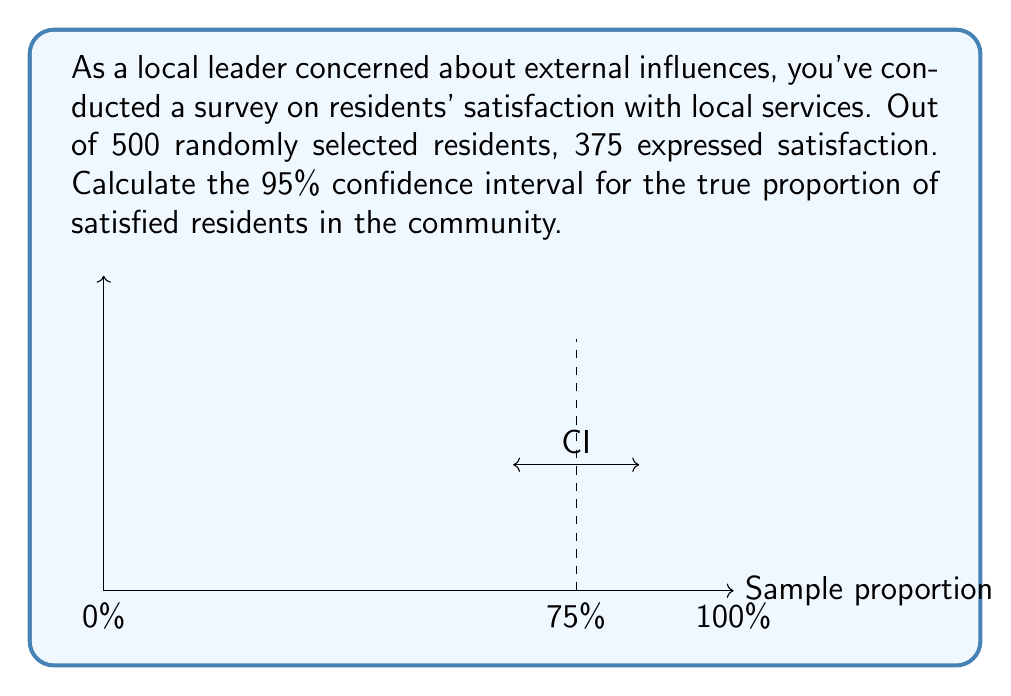Could you help me with this problem? Let's approach this step-by-step:

1) First, we need to calculate the sample proportion:
   $\hat{p} = \frac{375}{500} = 0.75$ or 75%

2) The formula for the confidence interval is:
   $$\hat{p} \pm z_{\alpha/2} \sqrt{\frac{\hat{p}(1-\hat{p})}{n}}$$
   where $z_{\alpha/2}$ is the critical value for a 95% confidence interval (1.96)

3) Let's calculate the standard error:
   $$SE = \sqrt{\frac{\hat{p}(1-\hat{p})}{n}} = \sqrt{\frac{0.75(1-0.75)}{500}} = \sqrt{\frac{0.1875}{500}} = 0.0194$$

4) Now we can calculate the margin of error:
   $$ME = z_{\alpha/2} * SE = 1.96 * 0.0194 = 0.0380$$

5) Finally, we can construct the confidence interval:
   Lower bound: $0.75 - 0.0380 = 0.7120$ or 71.20%
   Upper bound: $0.75 + 0.0380 = 0.7880$ or 78.80%

Therefore, we can be 95% confident that the true proportion of satisfied residents in the community falls between 71.20% and 78.80%.
Answer: (0.7120, 0.7880) or (71.20%, 78.80%) 